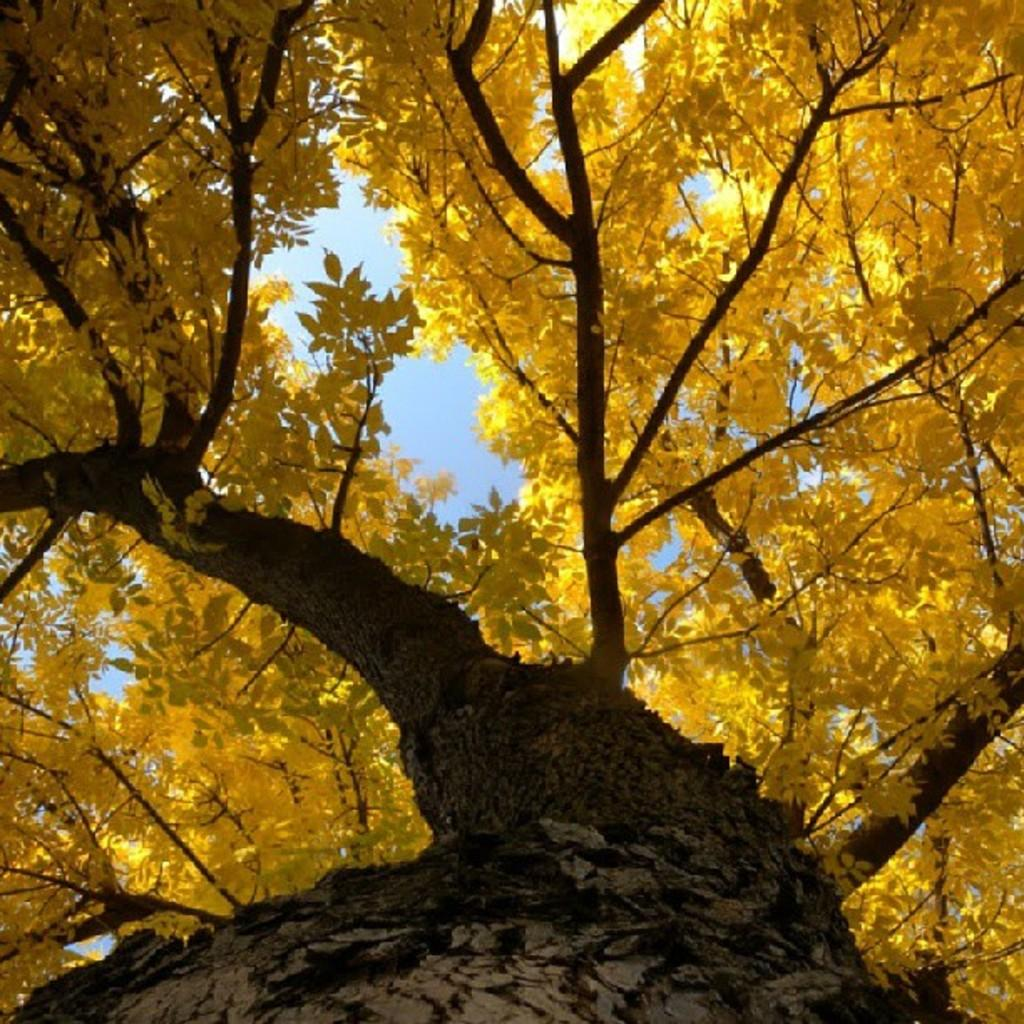What type of plant can be seen in the image? There is a tree in the image. What type of fiction is the tree reading in the image? There is no indication in the image that the tree is reading any fiction, as trees do not have the ability to read. 